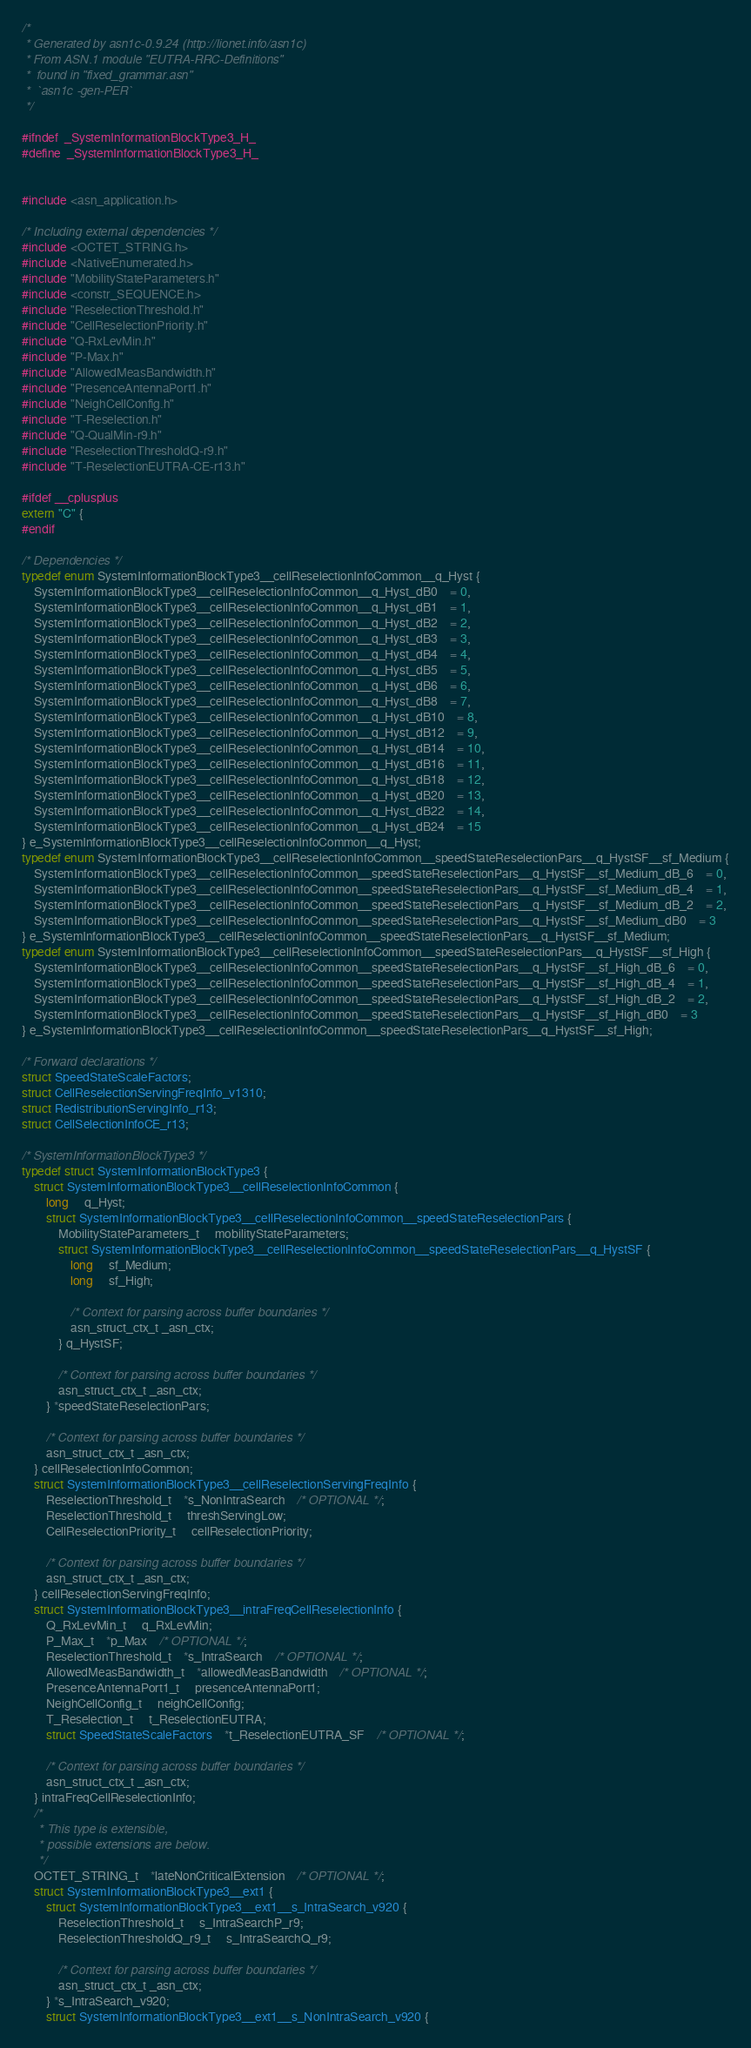Convert code to text. <code><loc_0><loc_0><loc_500><loc_500><_C_>/*
 * Generated by asn1c-0.9.24 (http://lionet.info/asn1c)
 * From ASN.1 module "EUTRA-RRC-Definitions"
 * 	found in "fixed_grammar.asn"
 * 	`asn1c -gen-PER`
 */

#ifndef	_SystemInformationBlockType3_H_
#define	_SystemInformationBlockType3_H_


#include <asn_application.h>

/* Including external dependencies */
#include <OCTET_STRING.h>
#include <NativeEnumerated.h>
#include "MobilityStateParameters.h"
#include <constr_SEQUENCE.h>
#include "ReselectionThreshold.h"
#include "CellReselectionPriority.h"
#include "Q-RxLevMin.h"
#include "P-Max.h"
#include "AllowedMeasBandwidth.h"
#include "PresenceAntennaPort1.h"
#include "NeighCellConfig.h"
#include "T-Reselection.h"
#include "Q-QualMin-r9.h"
#include "ReselectionThresholdQ-r9.h"
#include "T-ReselectionEUTRA-CE-r13.h"

#ifdef __cplusplus
extern "C" {
#endif

/* Dependencies */
typedef enum SystemInformationBlockType3__cellReselectionInfoCommon__q_Hyst {
	SystemInformationBlockType3__cellReselectionInfoCommon__q_Hyst_dB0	= 0,
	SystemInformationBlockType3__cellReselectionInfoCommon__q_Hyst_dB1	= 1,
	SystemInformationBlockType3__cellReselectionInfoCommon__q_Hyst_dB2	= 2,
	SystemInformationBlockType3__cellReselectionInfoCommon__q_Hyst_dB3	= 3,
	SystemInformationBlockType3__cellReselectionInfoCommon__q_Hyst_dB4	= 4,
	SystemInformationBlockType3__cellReselectionInfoCommon__q_Hyst_dB5	= 5,
	SystemInformationBlockType3__cellReselectionInfoCommon__q_Hyst_dB6	= 6,
	SystemInformationBlockType3__cellReselectionInfoCommon__q_Hyst_dB8	= 7,
	SystemInformationBlockType3__cellReselectionInfoCommon__q_Hyst_dB10	= 8,
	SystemInformationBlockType3__cellReselectionInfoCommon__q_Hyst_dB12	= 9,
	SystemInformationBlockType3__cellReselectionInfoCommon__q_Hyst_dB14	= 10,
	SystemInformationBlockType3__cellReselectionInfoCommon__q_Hyst_dB16	= 11,
	SystemInformationBlockType3__cellReselectionInfoCommon__q_Hyst_dB18	= 12,
	SystemInformationBlockType3__cellReselectionInfoCommon__q_Hyst_dB20	= 13,
	SystemInformationBlockType3__cellReselectionInfoCommon__q_Hyst_dB22	= 14,
	SystemInformationBlockType3__cellReselectionInfoCommon__q_Hyst_dB24	= 15
} e_SystemInformationBlockType3__cellReselectionInfoCommon__q_Hyst;
typedef enum SystemInformationBlockType3__cellReselectionInfoCommon__speedStateReselectionPars__q_HystSF__sf_Medium {
	SystemInformationBlockType3__cellReselectionInfoCommon__speedStateReselectionPars__q_HystSF__sf_Medium_dB_6	= 0,
	SystemInformationBlockType3__cellReselectionInfoCommon__speedStateReselectionPars__q_HystSF__sf_Medium_dB_4	= 1,
	SystemInformationBlockType3__cellReselectionInfoCommon__speedStateReselectionPars__q_HystSF__sf_Medium_dB_2	= 2,
	SystemInformationBlockType3__cellReselectionInfoCommon__speedStateReselectionPars__q_HystSF__sf_Medium_dB0	= 3
} e_SystemInformationBlockType3__cellReselectionInfoCommon__speedStateReselectionPars__q_HystSF__sf_Medium;
typedef enum SystemInformationBlockType3__cellReselectionInfoCommon__speedStateReselectionPars__q_HystSF__sf_High {
	SystemInformationBlockType3__cellReselectionInfoCommon__speedStateReselectionPars__q_HystSF__sf_High_dB_6	= 0,
	SystemInformationBlockType3__cellReselectionInfoCommon__speedStateReselectionPars__q_HystSF__sf_High_dB_4	= 1,
	SystemInformationBlockType3__cellReselectionInfoCommon__speedStateReselectionPars__q_HystSF__sf_High_dB_2	= 2,
	SystemInformationBlockType3__cellReselectionInfoCommon__speedStateReselectionPars__q_HystSF__sf_High_dB0	= 3
} e_SystemInformationBlockType3__cellReselectionInfoCommon__speedStateReselectionPars__q_HystSF__sf_High;

/* Forward declarations */
struct SpeedStateScaleFactors;
struct CellReselectionServingFreqInfo_v1310;
struct RedistributionServingInfo_r13;
struct CellSelectionInfoCE_r13;

/* SystemInformationBlockType3 */
typedef struct SystemInformationBlockType3 {
	struct SystemInformationBlockType3__cellReselectionInfoCommon {
		long	 q_Hyst;
		struct SystemInformationBlockType3__cellReselectionInfoCommon__speedStateReselectionPars {
			MobilityStateParameters_t	 mobilityStateParameters;
			struct SystemInformationBlockType3__cellReselectionInfoCommon__speedStateReselectionPars__q_HystSF {
				long	 sf_Medium;
				long	 sf_High;
				
				/* Context for parsing across buffer boundaries */
				asn_struct_ctx_t _asn_ctx;
			} q_HystSF;
			
			/* Context for parsing across buffer boundaries */
			asn_struct_ctx_t _asn_ctx;
		} *speedStateReselectionPars;
		
		/* Context for parsing across buffer boundaries */
		asn_struct_ctx_t _asn_ctx;
	} cellReselectionInfoCommon;
	struct SystemInformationBlockType3__cellReselectionServingFreqInfo {
		ReselectionThreshold_t	*s_NonIntraSearch	/* OPTIONAL */;
		ReselectionThreshold_t	 threshServingLow;
		CellReselectionPriority_t	 cellReselectionPriority;
		
		/* Context for parsing across buffer boundaries */
		asn_struct_ctx_t _asn_ctx;
	} cellReselectionServingFreqInfo;
	struct SystemInformationBlockType3__intraFreqCellReselectionInfo {
		Q_RxLevMin_t	 q_RxLevMin;
		P_Max_t	*p_Max	/* OPTIONAL */;
		ReselectionThreshold_t	*s_IntraSearch	/* OPTIONAL */;
		AllowedMeasBandwidth_t	*allowedMeasBandwidth	/* OPTIONAL */;
		PresenceAntennaPort1_t	 presenceAntennaPort1;
		NeighCellConfig_t	 neighCellConfig;
		T_Reselection_t	 t_ReselectionEUTRA;
		struct SpeedStateScaleFactors	*t_ReselectionEUTRA_SF	/* OPTIONAL */;
		
		/* Context for parsing across buffer boundaries */
		asn_struct_ctx_t _asn_ctx;
	} intraFreqCellReselectionInfo;
	/*
	 * This type is extensible,
	 * possible extensions are below.
	 */
	OCTET_STRING_t	*lateNonCriticalExtension	/* OPTIONAL */;
	struct SystemInformationBlockType3__ext1 {
		struct SystemInformationBlockType3__ext1__s_IntraSearch_v920 {
			ReselectionThreshold_t	 s_IntraSearchP_r9;
			ReselectionThresholdQ_r9_t	 s_IntraSearchQ_r9;
			
			/* Context for parsing across buffer boundaries */
			asn_struct_ctx_t _asn_ctx;
		} *s_IntraSearch_v920;
		struct SystemInformationBlockType3__ext1__s_NonIntraSearch_v920 {</code> 